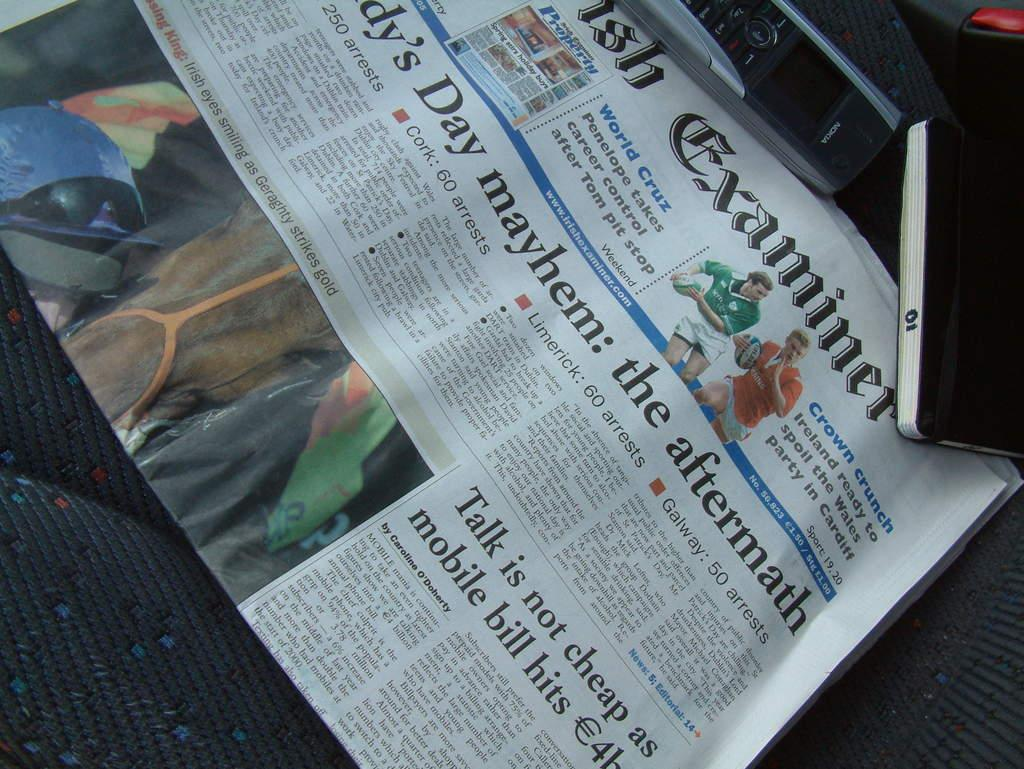<image>
Offer a succinct explanation of the picture presented. A newspaper featuring an article that is titled talk is not cheap as mobile bill hits. 